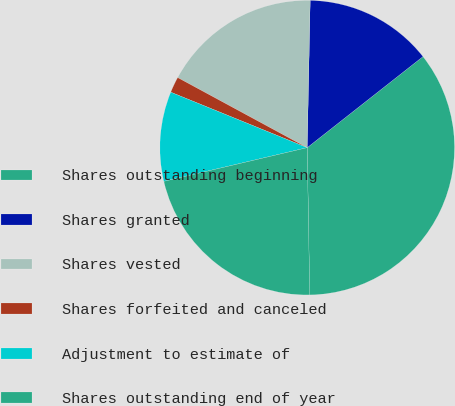Convert chart to OTSL. <chart><loc_0><loc_0><loc_500><loc_500><pie_chart><fcel>Shares outstanding beginning<fcel>Shares granted<fcel>Shares vested<fcel>Shares forfeited and canceled<fcel>Adjustment to estimate of<fcel>Shares outstanding end of year<nl><fcel>35.34%<fcel>14.07%<fcel>17.43%<fcel>1.75%<fcel>9.82%<fcel>21.6%<nl></chart> 